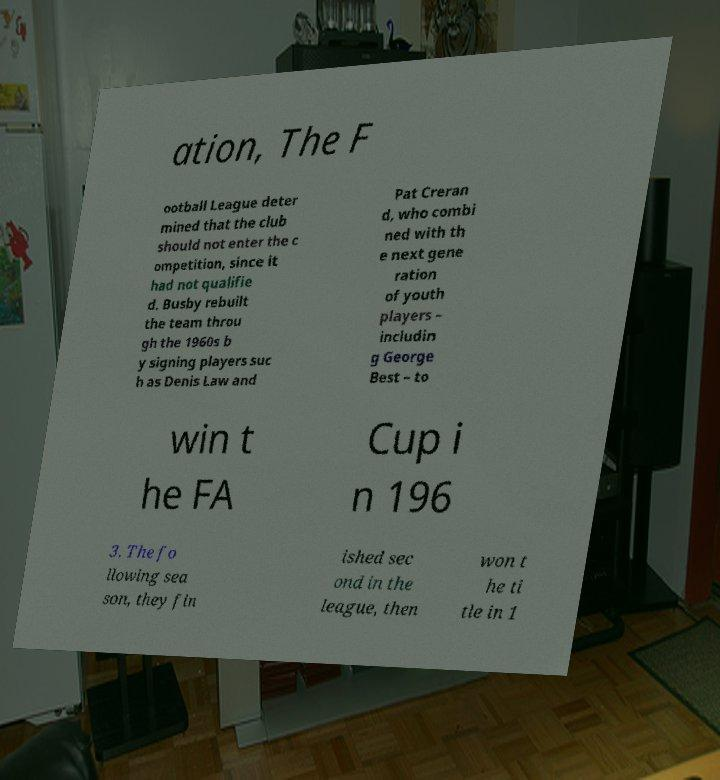Can you read and provide the text displayed in the image?This photo seems to have some interesting text. Can you extract and type it out for me? ation, The F ootball League deter mined that the club should not enter the c ompetition, since it had not qualifie d. Busby rebuilt the team throu gh the 1960s b y signing players suc h as Denis Law and Pat Creran d, who combi ned with th e next gene ration of youth players – includin g George Best – to win t he FA Cup i n 196 3. The fo llowing sea son, they fin ished sec ond in the league, then won t he ti tle in 1 